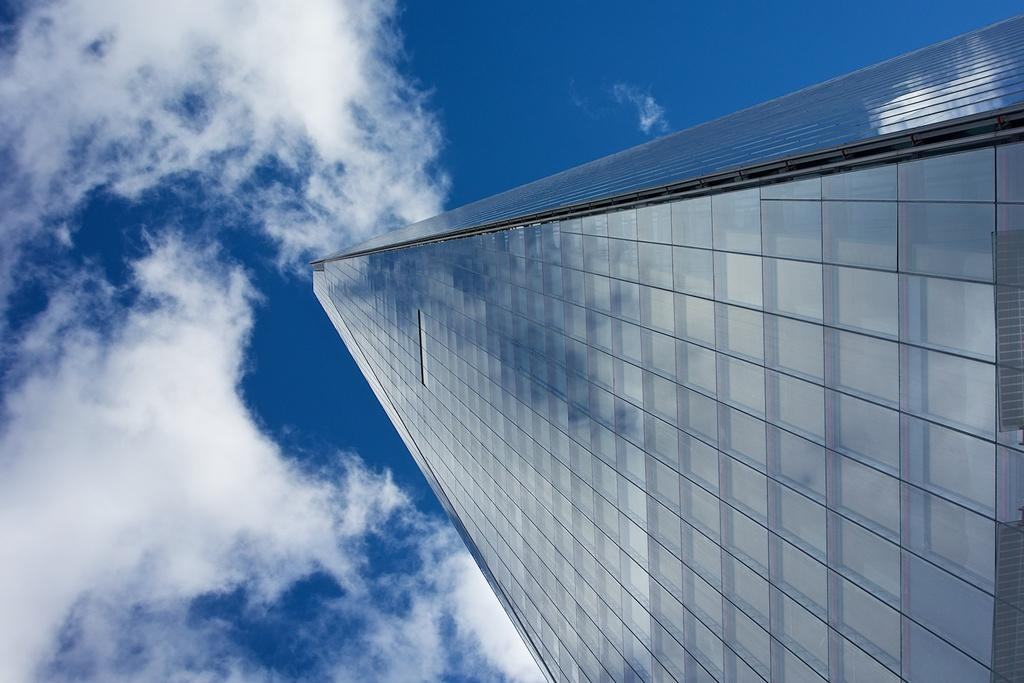What structure is located on the right side of the image? There is a building on the right side of the image. What is visible in the background of the image? Sky is visible in the background of the image. What can be seen in the sky? Clouds are present in the sky. What is the weight of the cellar in the image? There is no cellar present in the image, so it is not possible to determine its weight. 